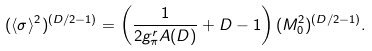<formula> <loc_0><loc_0><loc_500><loc_500>( \langle \sigma \rangle ^ { 2 } ) ^ { ( D / 2 - 1 ) } = \left ( \frac { 1 } { 2 g _ { \pi } ^ { r } A ( D ) } + D - 1 \right ) ( M _ { 0 } ^ { 2 } ) ^ { ( D / 2 - 1 ) } .</formula> 